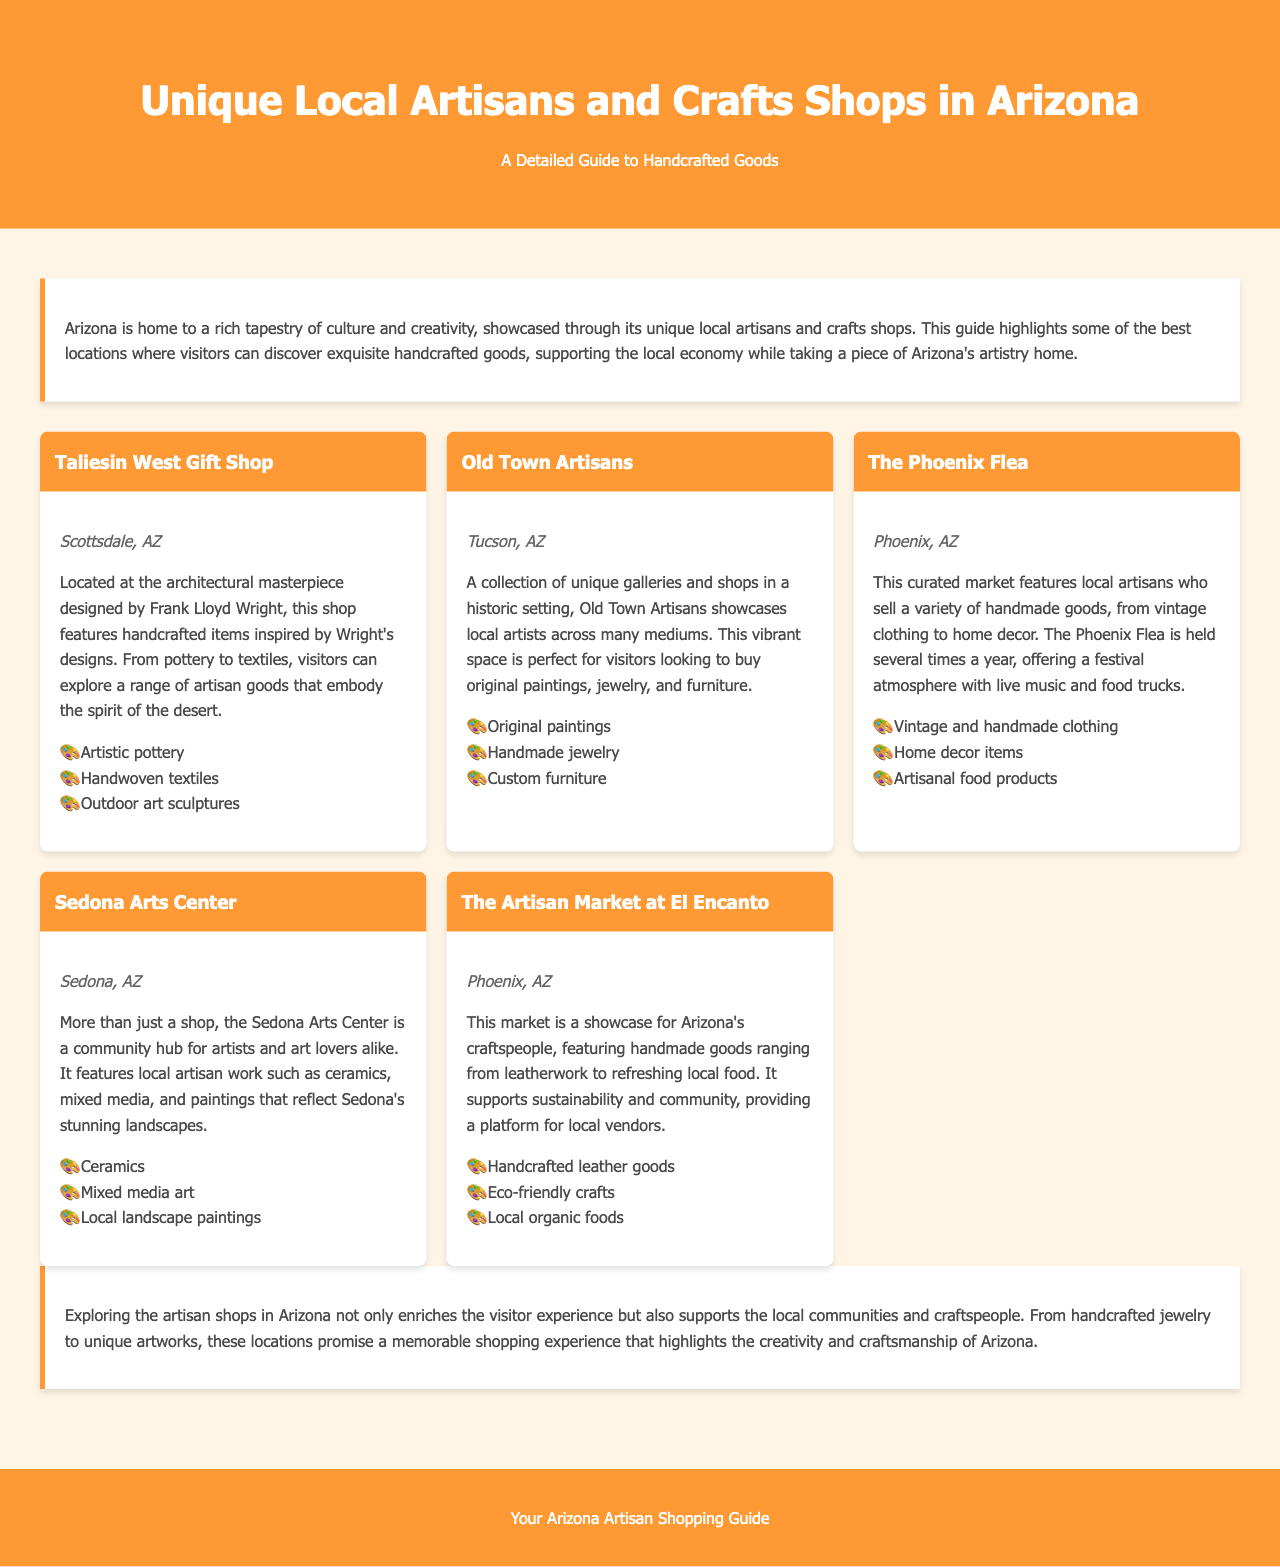What is the title of the document? The title of the document is showcased at the top of the rendered document.
Answer: Unique Local Artisans and Crafts Shops in Arizona Which city is the Taliesin West Gift Shop located in? The document clearly states the location of the Taliesin West Gift Shop next to its title.
Answer: Scottsdale, AZ What type of products does Old Town Artisans offer? The document describes the type of items available at Old Town Artisans in its section.
Answer: Original paintings, Handmade jewelry, Custom furniture How many shops are listed in the document? The document presents a total of five distinct artisan shops within its content.
Answer: Five What is the purpose of the Artisan Market at El Encanto? The document explains the role of the Artisan Market at El Encanto in promoting local craftspeople.
Answer: Showcase for Arizona's craftspeople What is the common theme among the shops listed? The document emphasizes a central idea regarding the products and contributions of the shops highlighted.
Answer: Handcrafted goods What unique experience does the Phoenix Flea offer? The document highlights the atmosphere and experience during events at the Phoenix Flea marketplace.
Answer: Festival atmosphere with live music and food trucks Which type of art can be found at the Sedona Arts Center? The document lists specific types of artisan work that can be found at the Sedona Arts Center.
Answer: Ceramics, Mixed media art, Local landscape paintings 